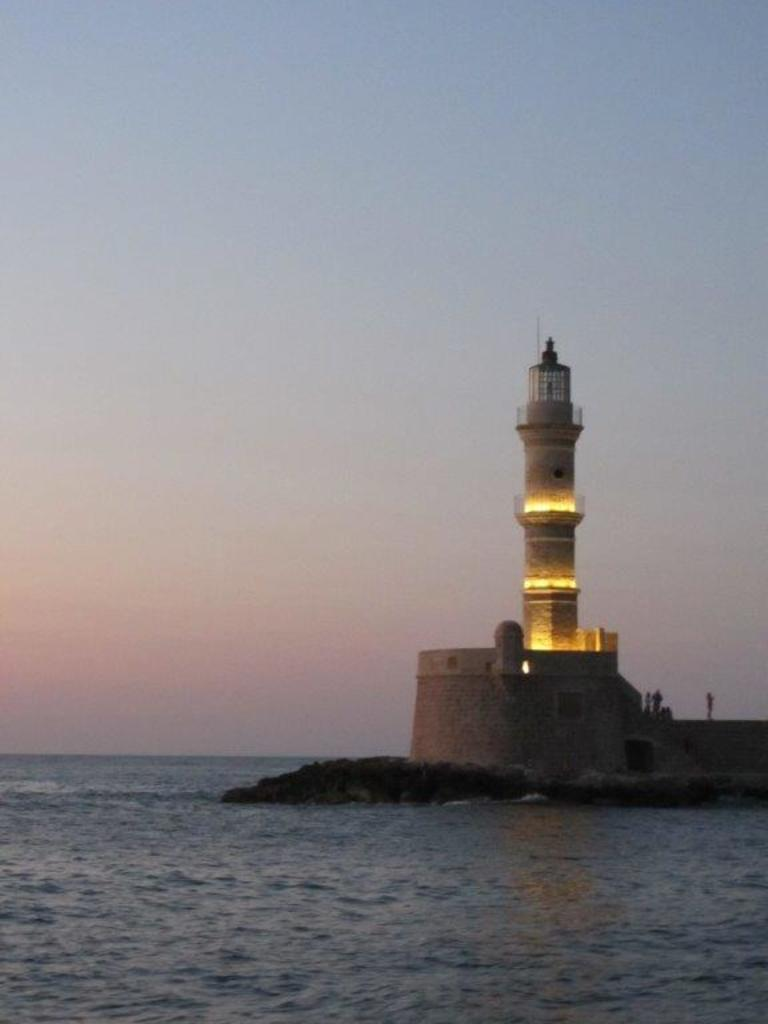What is the main structure visible in the image? There is a lighthouse in the image. Are there any people present near the lighthouse? Yes, people are standing on the lighthouse. What type of environment surrounds the lighthouse? There is water surrounding the lighthouse. What type of company is operating the lighthouse in the image? There is no indication of a company operating the lighthouse in the image. What type of blade can be seen in the image? There are no blades present in the image. 